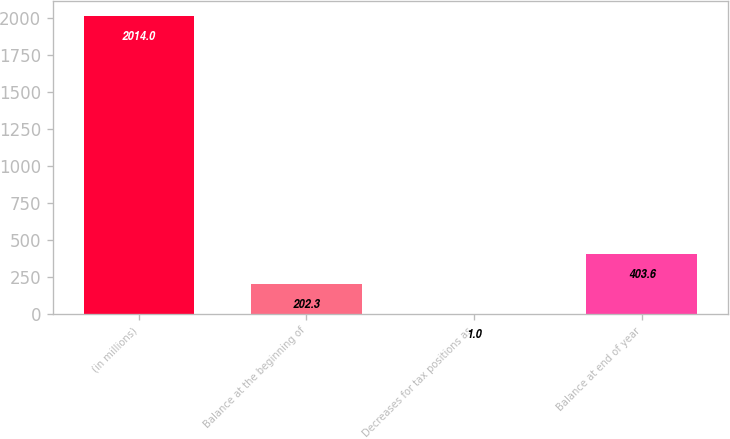Convert chart. <chart><loc_0><loc_0><loc_500><loc_500><bar_chart><fcel>(in millions)<fcel>Balance at the beginning of<fcel>Decreases for tax positions as<fcel>Balance at end of year<nl><fcel>2014<fcel>202.3<fcel>1<fcel>403.6<nl></chart> 